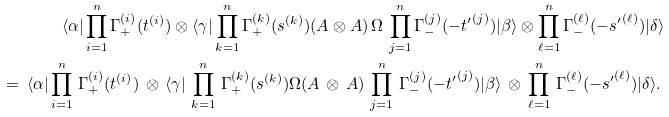Convert formula to latex. <formula><loc_0><loc_0><loc_500><loc_500>\langle \alpha | \prod _ { i = 1 } ^ { n } \Gamma _ { + } ^ { ( i ) } ( { t } ^ { ( i ) } ) \otimes \langle \gamma | \prod _ { k = 1 } ^ { n } \Gamma _ { + } ^ { ( k ) } ( { s } ^ { ( k ) } ) ( A \otimes A ) \, \Omega \, \prod _ { j = 1 } ^ { n } \Gamma _ { - } ^ { ( j ) } ( - { t ^ { \prime } } ^ { ( j ) } ) | \beta \rangle \otimes \prod _ { \ell = 1 } ^ { n } \Gamma _ { - } ^ { ( \ell ) } ( - { s ^ { \prime } } ^ { ( \ell ) } ) | \delta \rangle \\ \quad = \, \langle \alpha | \prod _ { i = 1 } ^ { n } \, \Gamma _ { + } ^ { ( i ) } ( { t } ^ { ( i ) } ) \, \otimes \, \langle \gamma | \, \prod _ { k = 1 } ^ { n } \, \Gamma _ { + } ^ { ( k ) } ( { s } ^ { ( k ) } ) \Omega ( A \, \otimes \, A ) \, \prod _ { j = 1 } ^ { n } \, \Gamma _ { - } ^ { ( j ) } ( - { t ^ { \prime } } ^ { ( j ) } ) | \beta \rangle \, \otimes \, \prod _ { \ell = 1 } ^ { n } \, \Gamma _ { - } ^ { ( \ell ) } ( - { s ^ { \prime } } ^ { ( \ell ) } ) | \delta \rangle . \,</formula> 